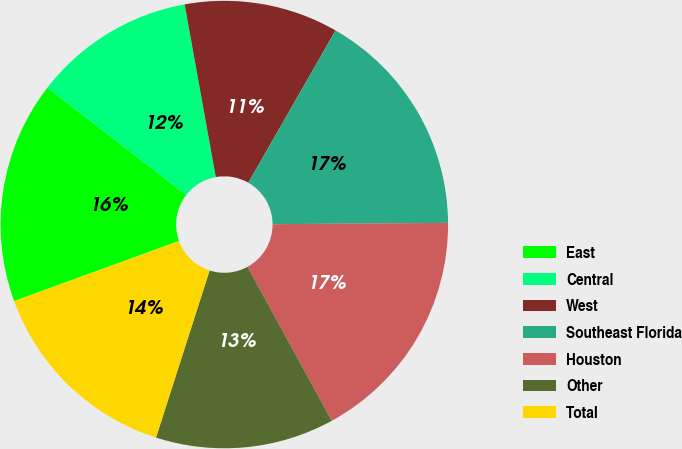Convert chart to OTSL. <chart><loc_0><loc_0><loc_500><loc_500><pie_chart><fcel>East<fcel>Central<fcel>West<fcel>Southeast Florida<fcel>Houston<fcel>Other<fcel>Total<nl><fcel>16.04%<fcel>11.68%<fcel>11.12%<fcel>16.6%<fcel>17.15%<fcel>12.91%<fcel>14.5%<nl></chart> 